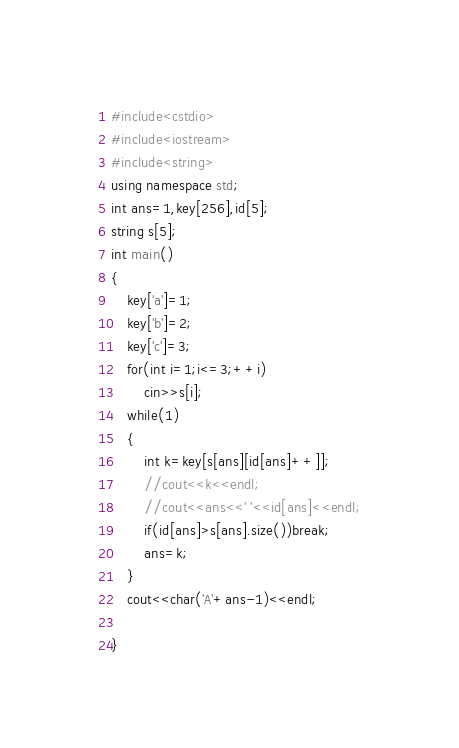<code> <loc_0><loc_0><loc_500><loc_500><_C++_>#include<cstdio>
#include<iostream>
#include<string>
using namespace std;
int ans=1,key[256],id[5];
string s[5];
int main()
{
	key['a']=1;
	key['b']=2;
	key['c']=3;
	for(int i=1;i<=3;++i)
		cin>>s[i];
	while(1)
	{
		int k=key[s[ans][id[ans]++]];
		//cout<<k<<endl;
		//cout<<ans<<' '<<id[ans]<<endl;
		if(id[ans]>s[ans].size())break;
		ans=k;
	}
	cout<<char('A'+ans-1)<<endl;

}</code> 